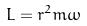Convert formula to latex. <formula><loc_0><loc_0><loc_500><loc_500>L = r ^ { 2 } m \omega</formula> 